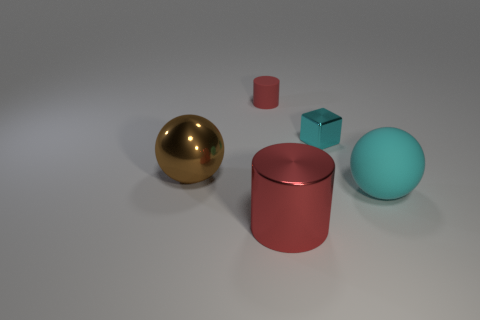Add 4 matte things. How many objects exist? 9 Subtract all balls. How many objects are left? 3 Subtract 0 purple cylinders. How many objects are left? 5 Subtract all cyan rubber objects. Subtract all metal spheres. How many objects are left? 3 Add 2 tiny red rubber cylinders. How many tiny red rubber cylinders are left? 3 Add 3 large rubber balls. How many large rubber balls exist? 4 